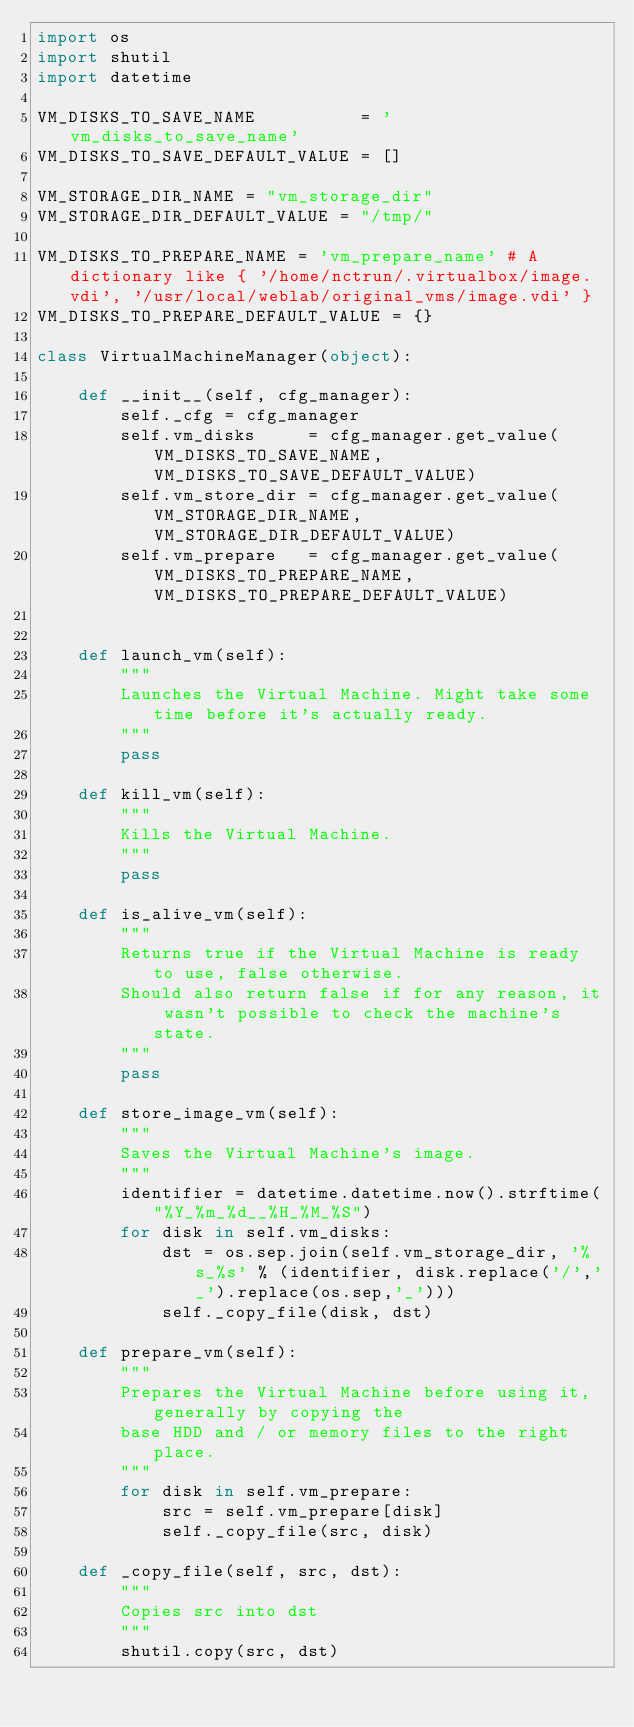Convert code to text. <code><loc_0><loc_0><loc_500><loc_500><_Python_>import os
import shutil
import datetime

VM_DISKS_TO_SAVE_NAME          = 'vm_disks_to_save_name'
VM_DISKS_TO_SAVE_DEFAULT_VALUE = []

VM_STORAGE_DIR_NAME = "vm_storage_dir"
VM_STORAGE_DIR_DEFAULT_VALUE = "/tmp/"

VM_DISKS_TO_PREPARE_NAME = 'vm_prepare_name' # A dictionary like { '/home/nctrun/.virtualbox/image.vdi', '/usr/local/weblab/original_vms/image.vdi' }
VM_DISKS_TO_PREPARE_DEFAULT_VALUE = {}

class VirtualMachineManager(object):
    
    def __init__(self, cfg_manager):
        self._cfg = cfg_manager
        self.vm_disks     = cfg_manager.get_value(VM_DISKS_TO_SAVE_NAME,    VM_DISKS_TO_SAVE_DEFAULT_VALUE)
        self.vm_store_dir = cfg_manager.get_value(VM_STORAGE_DIR_NAME,      VM_STORAGE_DIR_DEFAULT_VALUE)
        self.vm_prepare   = cfg_manager.get_value(VM_DISKS_TO_PREPARE_NAME, VM_DISKS_TO_PREPARE_DEFAULT_VALUE)
    

    def launch_vm(self):
        """
        Launches the Virtual Machine. Might take some time before it's actually ready.
        """
        pass
    
    def kill_vm(self):
        """
        Kills the Virtual Machine.
        """
        pass
    
    def is_alive_vm(self):
        """
        Returns true if the Virtual Machine is ready to use, false otherwise.
        Should also return false if for any reason, it wasn't possible to check the machine's state.
        """
        pass
    
    def store_image_vm(self):
        """
        Saves the Virtual Machine's image.
        """
        identifier = datetime.datetime.now().strftime("%Y_%m_%d__%H_%M_%S")
        for disk in self.vm_disks:
            dst = os.sep.join(self.vm_storage_dir, '%s_%s' % (identifier, disk.replace('/','_').replace(os.sep,'_')))
            self._copy_file(disk, dst)

    def prepare_vm(self):
        """
        Prepares the Virtual Machine before using it, generally by copying the
        base HDD and / or memory files to the right place.
        """
        for disk in self.vm_prepare:
            src = self.vm_prepare[disk]
            self._copy_file(src, disk)

    def _copy_file(self, src, dst):
        """ 
        Copies src into dst
        """
        shutil.copy(src, dst)
    
</code> 